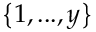<formula> <loc_0><loc_0><loc_500><loc_500>\left \{ 1 , \dots , y \right \}</formula> 